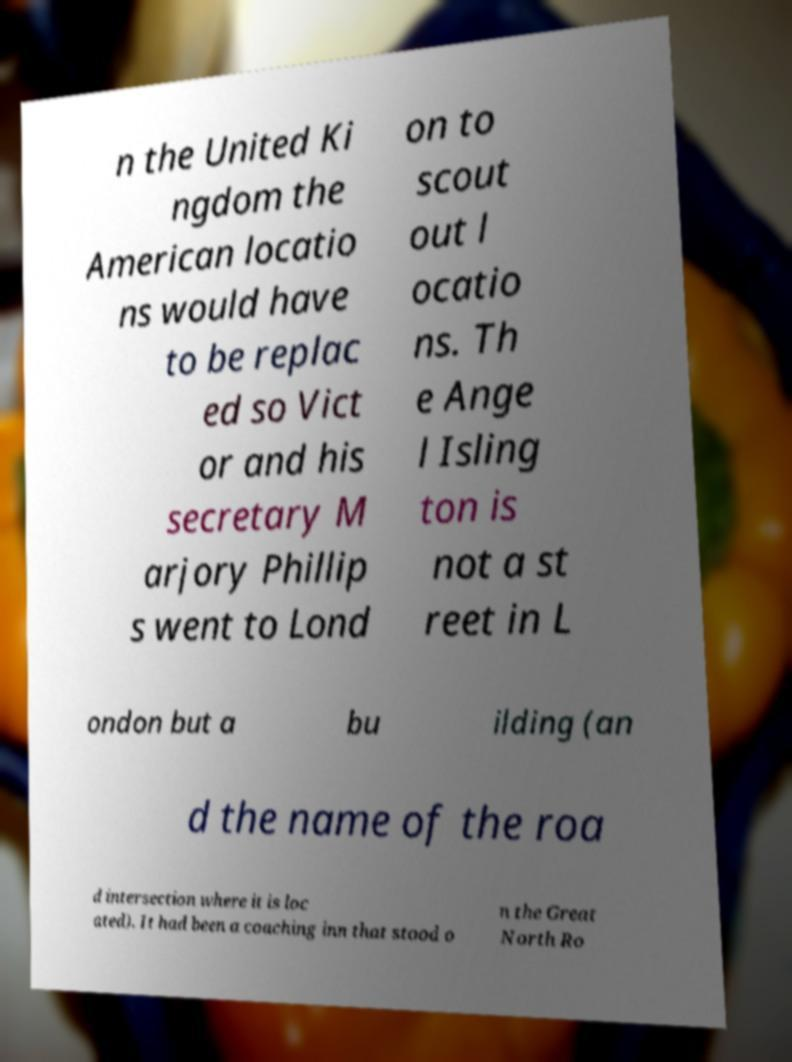For documentation purposes, I need the text within this image transcribed. Could you provide that? n the United Ki ngdom the American locatio ns would have to be replac ed so Vict or and his secretary M arjory Phillip s went to Lond on to scout out l ocatio ns. Th e Ange l Isling ton is not a st reet in L ondon but a bu ilding (an d the name of the roa d intersection where it is loc ated). It had been a coaching inn that stood o n the Great North Ro 